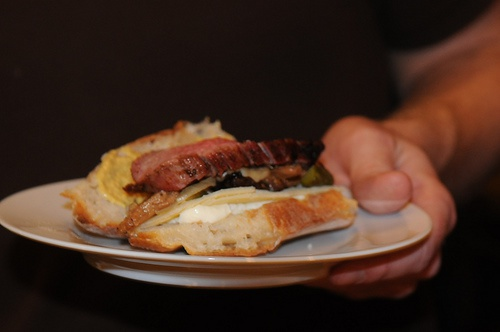Describe the objects in this image and their specific colors. I can see people in black, maroon, and brown tones, sandwich in black, brown, tan, and maroon tones, and hot dog in black, brown, tan, and maroon tones in this image. 